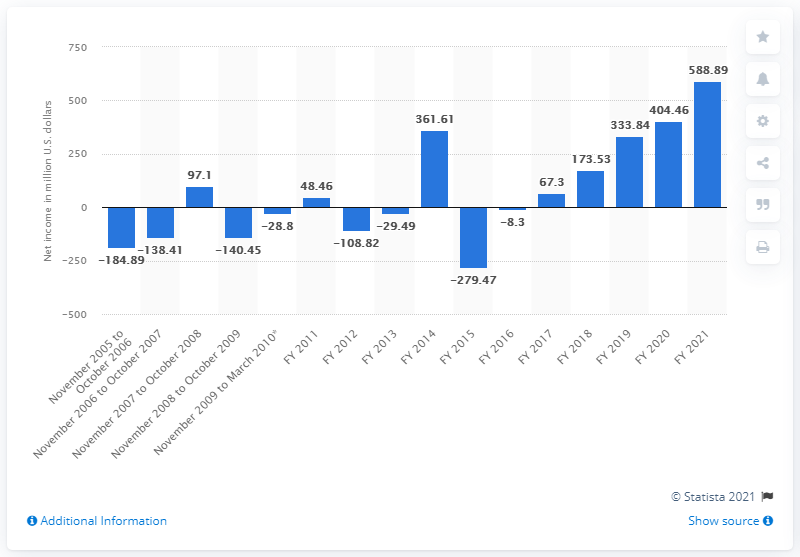What can be inferred about Take-Two's financial health from this graph? From the graph, Take-Two Interactive appears to have a generally improving financial health over the years, especially with the substantial growth in net income from 2020 to 2021. The company had faced years of losses as indicated by negative values but has been profitable in recent years, suggesting effective management and a successful turnaround in its operations. 